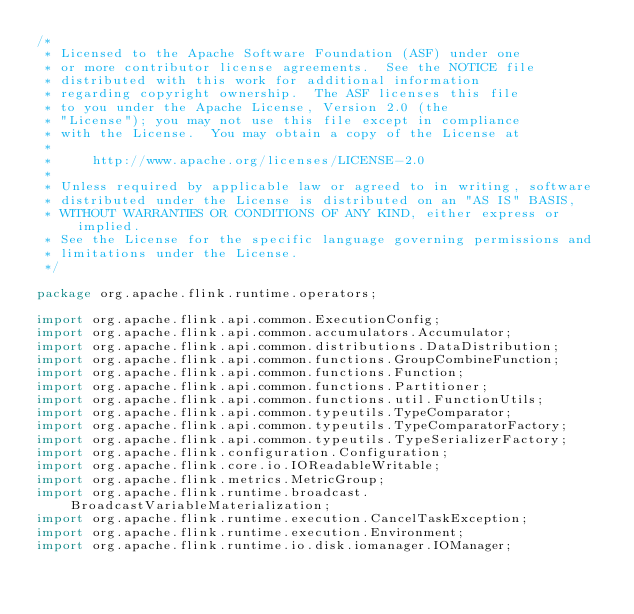Convert code to text. <code><loc_0><loc_0><loc_500><loc_500><_Java_>/*
 * Licensed to the Apache Software Foundation (ASF) under one
 * or more contributor license agreements.  See the NOTICE file
 * distributed with this work for additional information
 * regarding copyright ownership.  The ASF licenses this file
 * to you under the Apache License, Version 2.0 (the
 * "License"); you may not use this file except in compliance
 * with the License.  You may obtain a copy of the License at
 *
 *     http://www.apache.org/licenses/LICENSE-2.0
 *
 * Unless required by applicable law or agreed to in writing, software
 * distributed under the License is distributed on an "AS IS" BASIS,
 * WITHOUT WARRANTIES OR CONDITIONS OF ANY KIND, either express or implied.
 * See the License for the specific language governing permissions and
 * limitations under the License.
 */

package org.apache.flink.runtime.operators;

import org.apache.flink.api.common.ExecutionConfig;
import org.apache.flink.api.common.accumulators.Accumulator;
import org.apache.flink.api.common.distributions.DataDistribution;
import org.apache.flink.api.common.functions.GroupCombineFunction;
import org.apache.flink.api.common.functions.Function;
import org.apache.flink.api.common.functions.Partitioner;
import org.apache.flink.api.common.functions.util.FunctionUtils;
import org.apache.flink.api.common.typeutils.TypeComparator;
import org.apache.flink.api.common.typeutils.TypeComparatorFactory;
import org.apache.flink.api.common.typeutils.TypeSerializerFactory;
import org.apache.flink.configuration.Configuration;
import org.apache.flink.core.io.IOReadableWritable;
import org.apache.flink.metrics.MetricGroup;
import org.apache.flink.runtime.broadcast.BroadcastVariableMaterialization;
import org.apache.flink.runtime.execution.CancelTaskException;
import org.apache.flink.runtime.execution.Environment;
import org.apache.flink.runtime.io.disk.iomanager.IOManager;</code> 